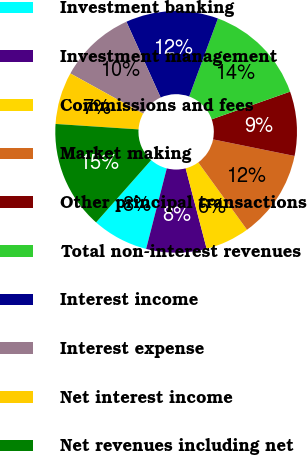Convert chart to OTSL. <chart><loc_0><loc_0><loc_500><loc_500><pie_chart><fcel>Investment banking<fcel>Investment management<fcel>Commissions and fees<fcel>Market making<fcel>Other principal transactions<fcel>Total non-interest revenues<fcel>Interest income<fcel>Interest expense<fcel>Net interest income<fcel>Net revenues including net<nl><fcel>7.53%<fcel>8.06%<fcel>5.91%<fcel>11.83%<fcel>8.6%<fcel>13.98%<fcel>12.37%<fcel>10.22%<fcel>6.99%<fcel>14.52%<nl></chart> 